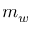<formula> <loc_0><loc_0><loc_500><loc_500>m _ { w }</formula> 